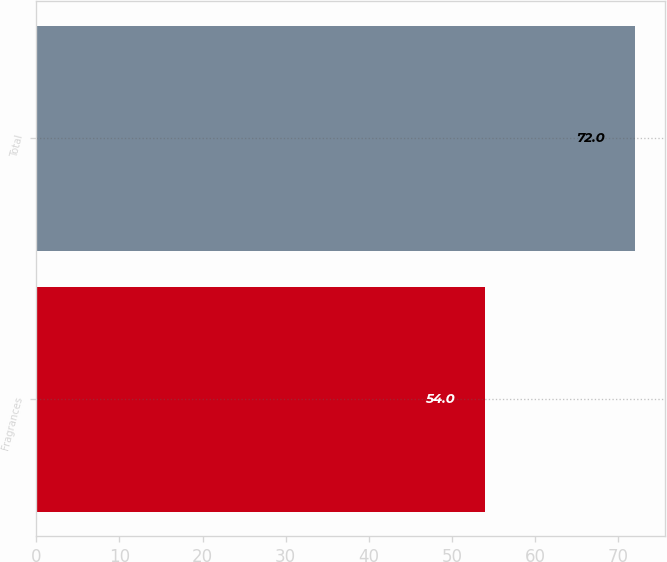Convert chart. <chart><loc_0><loc_0><loc_500><loc_500><bar_chart><fcel>Fragrances<fcel>Total<nl><fcel>54<fcel>72<nl></chart> 